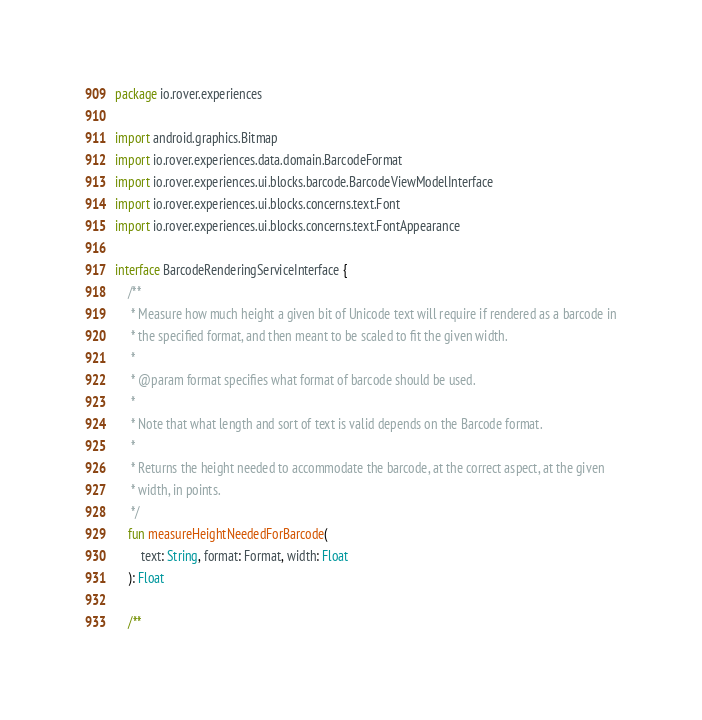Convert code to text. <code><loc_0><loc_0><loc_500><loc_500><_Kotlin_>package io.rover.experiences

import android.graphics.Bitmap
import io.rover.experiences.data.domain.BarcodeFormat
import io.rover.experiences.ui.blocks.barcode.BarcodeViewModelInterface
import io.rover.experiences.ui.blocks.concerns.text.Font
import io.rover.experiences.ui.blocks.concerns.text.FontAppearance

interface BarcodeRenderingServiceInterface {
    /**
     * Measure how much height a given bit of Unicode text will require if rendered as a barcode in
     * the specified format, and then meant to be scaled to fit the given width.
     *
     * @param format specifies what format of barcode should be used.
     *
     * Note that what length and sort of text is valid depends on the Barcode format.
     *
     * Returns the height needed to accommodate the barcode, at the correct aspect, at the given
     * width, in points.
     */
    fun measureHeightNeededForBarcode(
        text: String, format: Format, width: Float
    ): Float

    /**</code> 